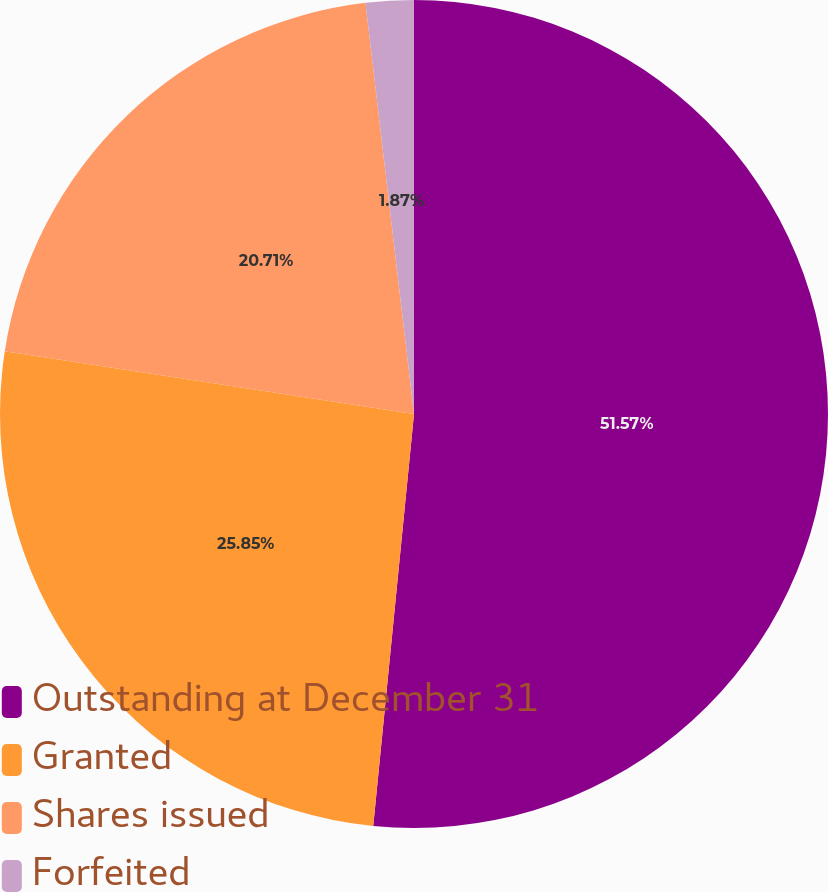Convert chart. <chart><loc_0><loc_0><loc_500><loc_500><pie_chart><fcel>Outstanding at December 31<fcel>Granted<fcel>Shares issued<fcel>Forfeited<nl><fcel>51.57%<fcel>25.85%<fcel>20.71%<fcel>1.87%<nl></chart> 